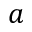Convert formula to latex. <formula><loc_0><loc_0><loc_500><loc_500>a</formula> 